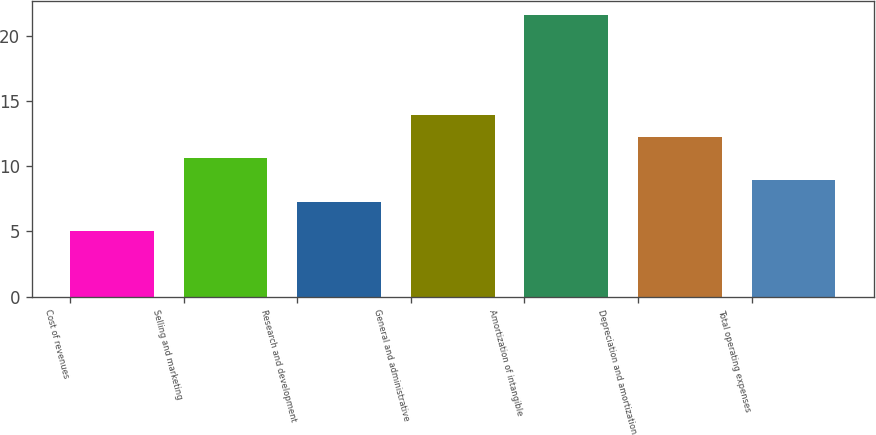<chart> <loc_0><loc_0><loc_500><loc_500><bar_chart><fcel>Cost of revenues<fcel>Selling and marketing<fcel>Research and development<fcel>General and administrative<fcel>Amortization of intangible<fcel>Depreciation and amortization<fcel>Total operating expenses<nl><fcel>5<fcel>10.62<fcel>7.3<fcel>13.94<fcel>21.6<fcel>12.28<fcel>8.96<nl></chart> 